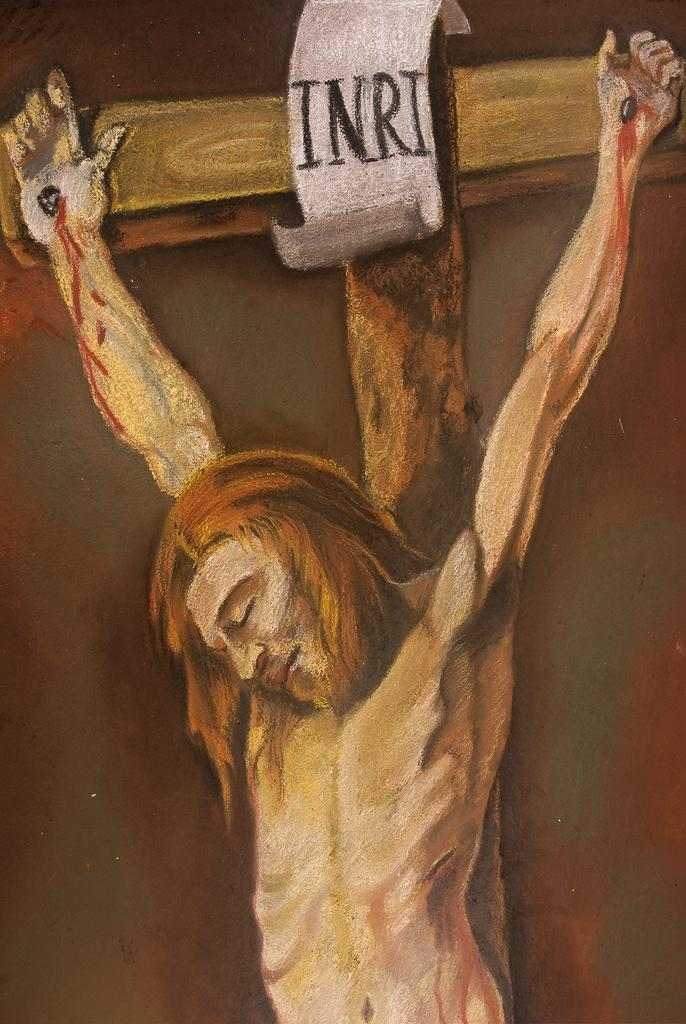What subject is depicted in the painting in the image? There is a painting of Jesus in the image. What is located behind the painting of Jesus? There is a cross behind the painting of Jesus. How does the painting of Jesus slip down the wall in the image? The painting of Jesus does not slip down the wall in the image; it is stationary. 